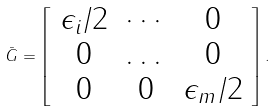<formula> <loc_0><loc_0><loc_500><loc_500>\bar { G } = \left [ \begin{array} { c c c } \epsilon _ { i } / 2 & \cdots & 0 \\ 0 & \dots & 0 \\ 0 & 0 & \epsilon _ { m } / 2 \end{array} \right ] .</formula> 